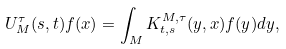<formula> <loc_0><loc_0><loc_500><loc_500>U _ { M } ^ { \tau } ( s , t ) f ( x ) = \int _ { M } K ^ { M , \tau } _ { t , s } ( y , x ) f ( y ) d y ,</formula> 